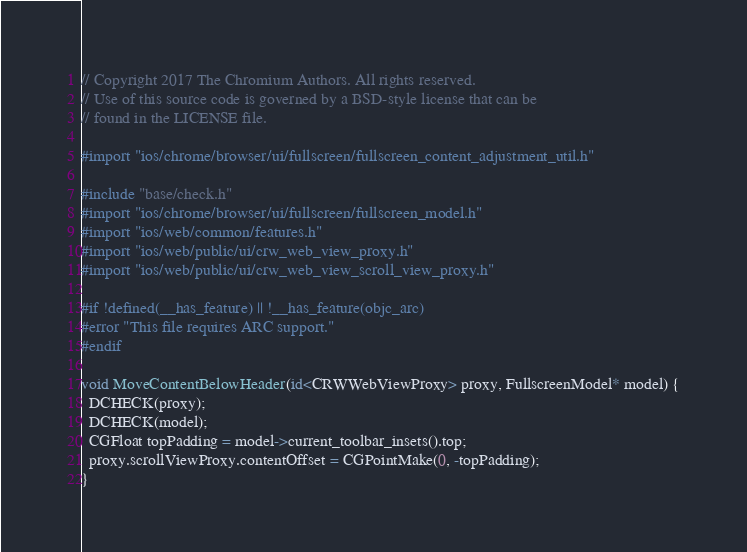Convert code to text. <code><loc_0><loc_0><loc_500><loc_500><_ObjectiveC_>// Copyright 2017 The Chromium Authors. All rights reserved.
// Use of this source code is governed by a BSD-style license that can be
// found in the LICENSE file.

#import "ios/chrome/browser/ui/fullscreen/fullscreen_content_adjustment_util.h"

#include "base/check.h"
#import "ios/chrome/browser/ui/fullscreen/fullscreen_model.h"
#import "ios/web/common/features.h"
#import "ios/web/public/ui/crw_web_view_proxy.h"
#import "ios/web/public/ui/crw_web_view_scroll_view_proxy.h"

#if !defined(__has_feature) || !__has_feature(objc_arc)
#error "This file requires ARC support."
#endif

void MoveContentBelowHeader(id<CRWWebViewProxy> proxy, FullscreenModel* model) {
  DCHECK(proxy);
  DCHECK(model);
  CGFloat topPadding = model->current_toolbar_insets().top;
  proxy.scrollViewProxy.contentOffset = CGPointMake(0, -topPadding);
}
</code> 